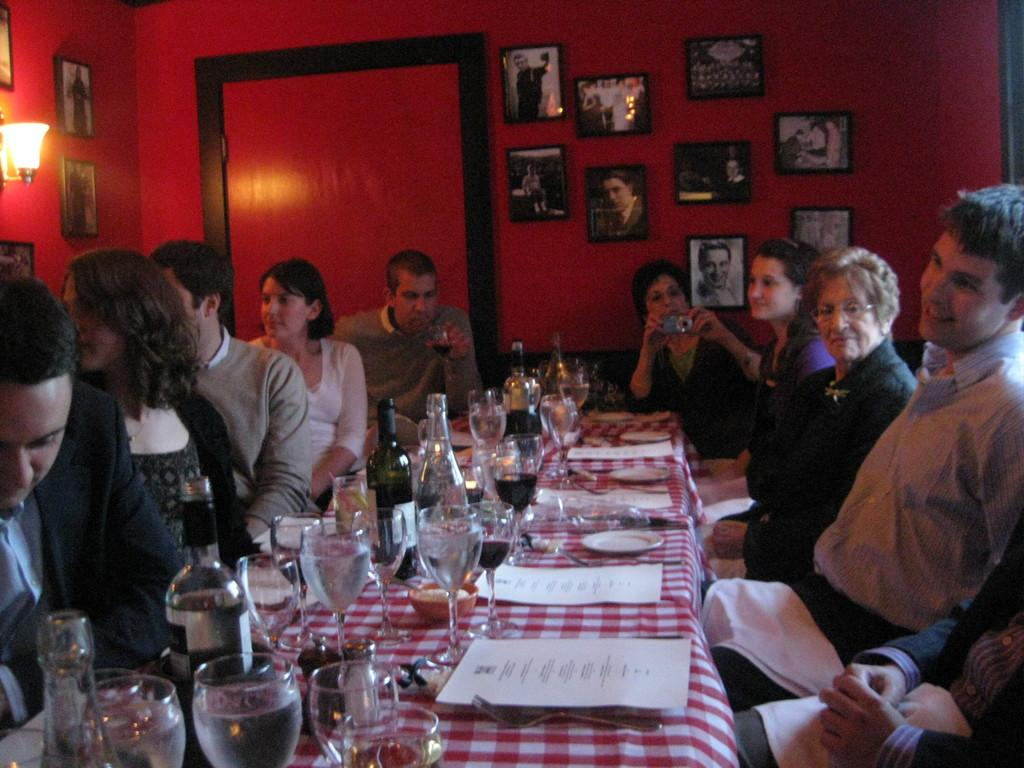What are the people in the image doing? People are sitting on the sofa in the image. What objects can be seen on the table? There is a glass, a bottle, a paper, and a spoon on the table. What is hanging on the wall? There are frames and a lamp on the wall. What type of quartz is visible in the image? There is no quartz present in the image. Is there any smoke visible in the image? There is no smoke visible in the image. 